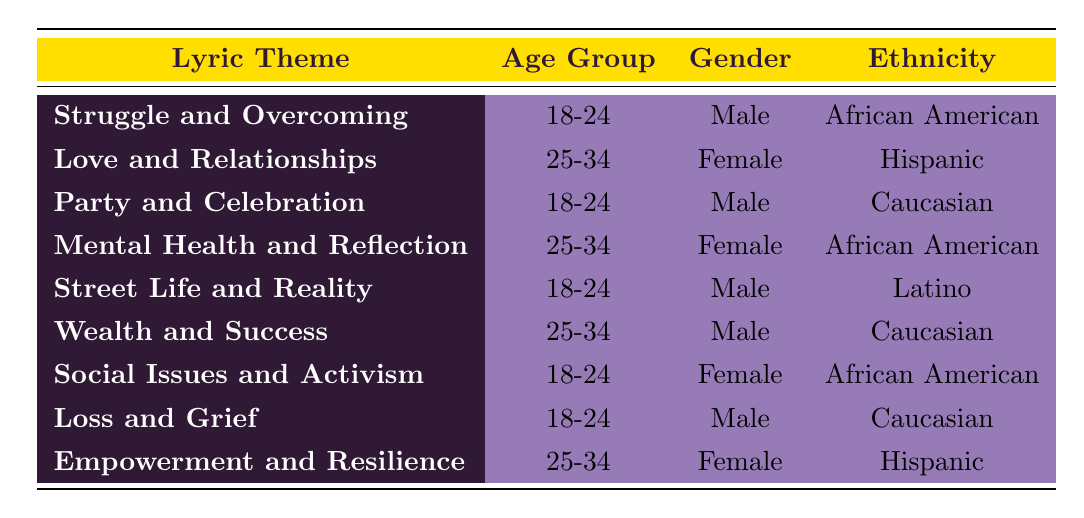What percentage of males aged 18-24 relate to the theme 'Loss and Grief'? The data shows that for males aged 18-24, the percentage that relates to the theme 'Loss and Grief' is specifically listed as 55%.
Answer: 55 Which gender has the highest percentage for the theme 'Mental Health and Reflection'? The theme 'Mental Health and Reflection' is associated with females aged 25-34, who have a percentage of 50%. This is the highest percentage for this theme compared to any others listed in the table.
Answer: Female What is the total percentage of females who listen to songs with themes of 'Social Issues and Activism' and 'Mental Health and Reflection'? The percentage for 'Social Issues and Activism' for females aged 18-24 is 60%, and for 'Mental Health and Reflection', it's 50% for females aged 25-34. Adding these gives 60 + 50 = 110%.
Answer: 110 Is the theme 'Wealth and Success' more popular among females or males aged 25-34? The theme 'Wealth and Success', with a percentage of 25%, is associated with males aged 25-34, while the highest percentage for females in the same age group is for 'Love and Relationships' at 40%. Therefore, 'Wealth and Success' is less popular among both genders.
Answer: No Which age group has the highest representation with the lyric theme 'Street Life and Reality'? The data indicates that the 'Street Life and Reality' theme is exclusively represented by males aged 18-24, who account for 45%. Since there are no other age groups listed for this theme, this is the highest representation.
Answer: 18-24 What are the percentages for male and female listeners who relate to the theme 'Empowerment and Resilience'? 'Empowerment and Resilience' is associated with females aged 25-34 at 35%. There are no male listeners associated with this theme in the provided data, so the male percentage is effectively 0%. Hence, the comparison is 35% (female) to 0% (male).
Answer: 35% female, 0% male How much higher is the percentage of females listening to 'Love and Relationships' compared to males for 'Party and Celebration'? The percentage of females for 'Love and Relationships' is 40%, while the percentage of males for 'Party and Celebration' is 30%. The difference is 40 - 30 = 10%.
Answer: 10% Which lyric theme has the highest percentage among African American females? The theme 'Mental Health and Reflection' has the highest percentage among African American females at 50%. When compared to other themes associated with females in the table, this is the highest noted.
Answer: Mental Health and Reflection 